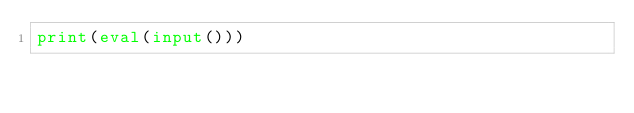Convert code to text. <code><loc_0><loc_0><loc_500><loc_500><_Python_>print(eval(input()))</code> 